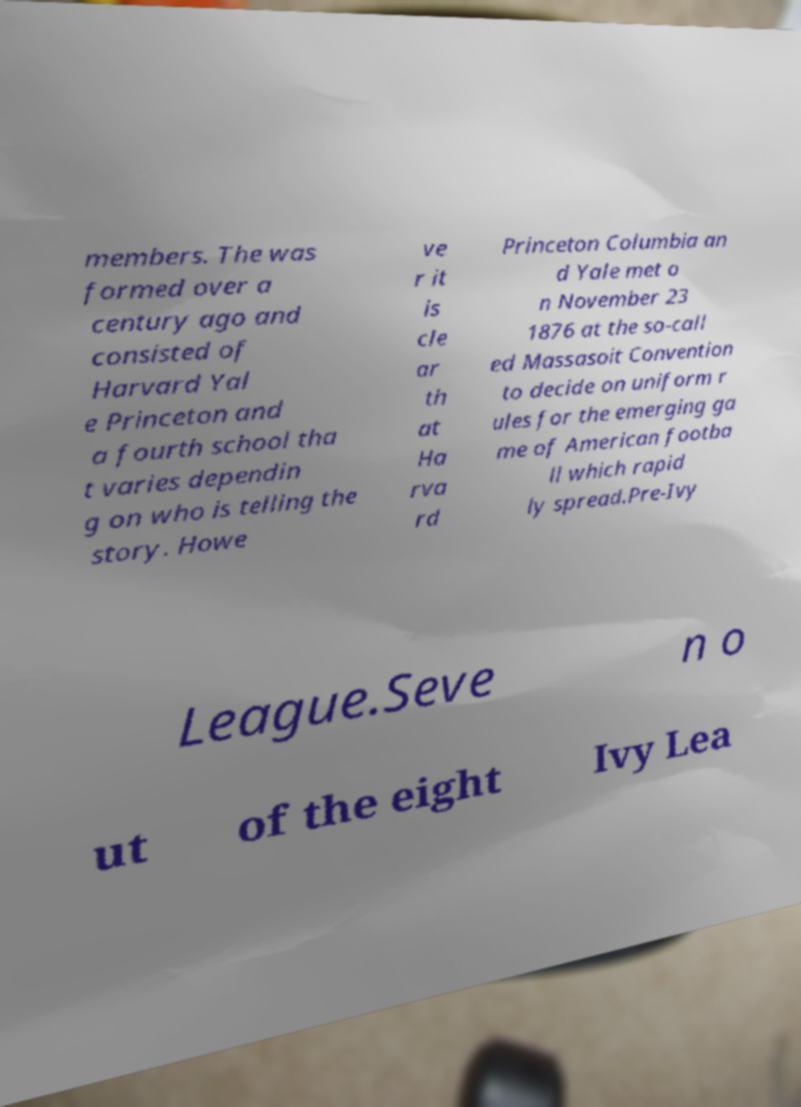Please read and relay the text visible in this image. What does it say? members. The was formed over a century ago and consisted of Harvard Yal e Princeton and a fourth school tha t varies dependin g on who is telling the story. Howe ve r it is cle ar th at Ha rva rd Princeton Columbia an d Yale met o n November 23 1876 at the so-call ed Massasoit Convention to decide on uniform r ules for the emerging ga me of American footba ll which rapid ly spread.Pre-Ivy League.Seve n o ut of the eight Ivy Lea 